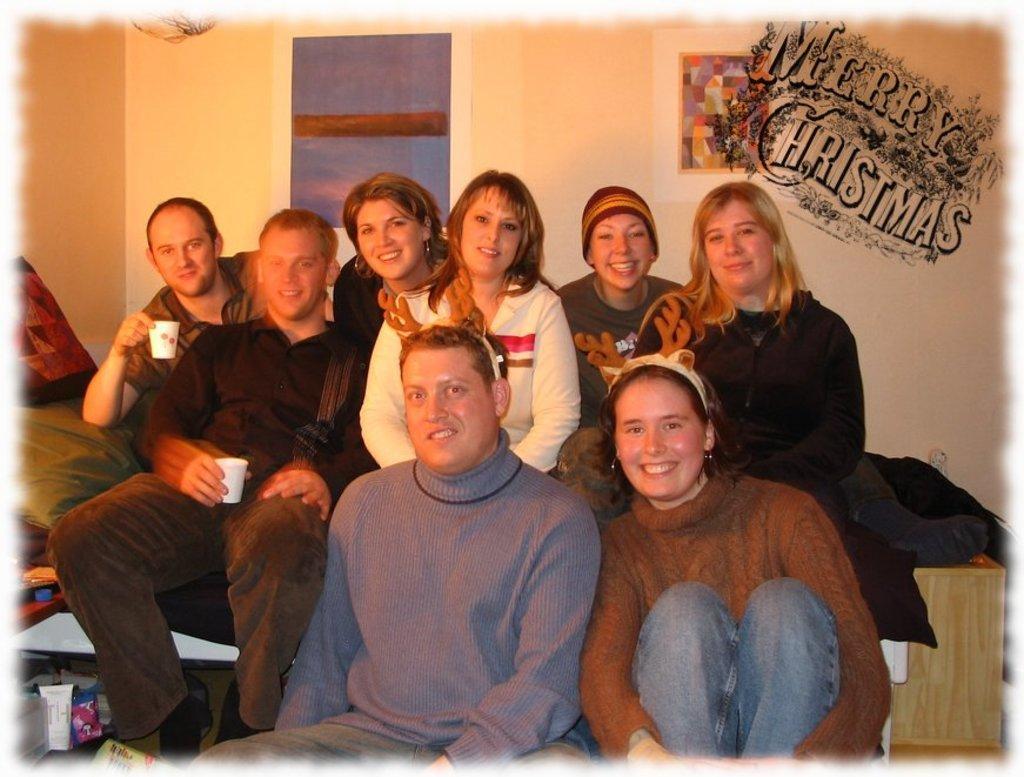In one or two sentences, can you explain what this image depicts? In this image we can see a group of people sitting and among them two are holding a cup and to the side we can see some objects. There is a table to the right side and in the background, we can see a wall with two posters and there is a text present on an image. 